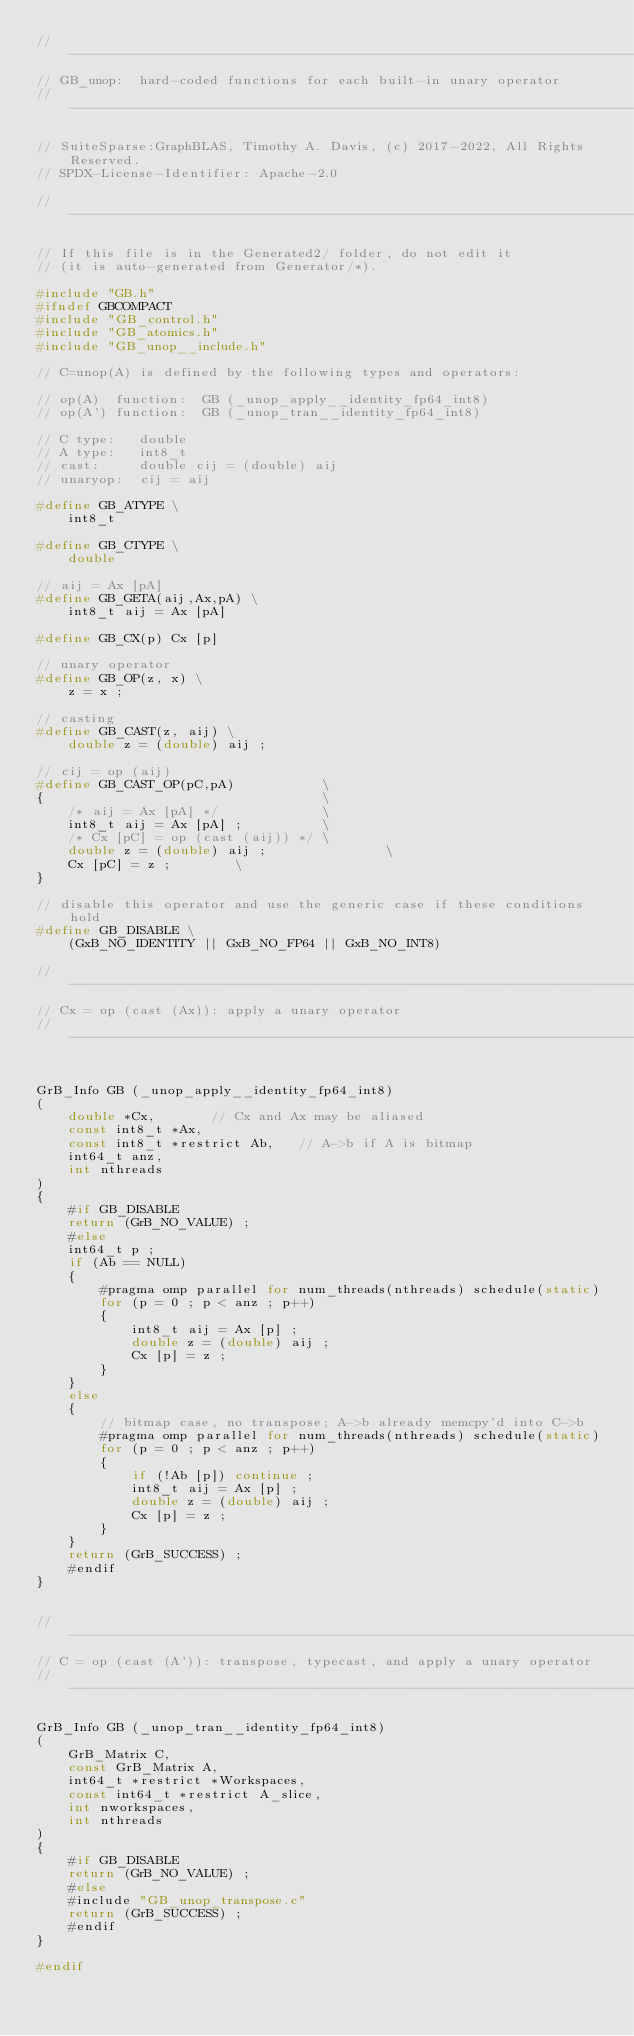Convert code to text. <code><loc_0><loc_0><loc_500><loc_500><_C_>//------------------------------------------------------------------------------
// GB_unop:  hard-coded functions for each built-in unary operator
//------------------------------------------------------------------------------

// SuiteSparse:GraphBLAS, Timothy A. Davis, (c) 2017-2022, All Rights Reserved.
// SPDX-License-Identifier: Apache-2.0

//------------------------------------------------------------------------------

// If this file is in the Generated2/ folder, do not edit it
// (it is auto-generated from Generator/*).

#include "GB.h"
#ifndef GBCOMPACT
#include "GB_control.h"
#include "GB_atomics.h"
#include "GB_unop__include.h"

// C=unop(A) is defined by the following types and operators:

// op(A)  function:  GB (_unop_apply__identity_fp64_int8)
// op(A') function:  GB (_unop_tran__identity_fp64_int8)

// C type:   double
// A type:   int8_t
// cast:     double cij = (double) aij
// unaryop:  cij = aij

#define GB_ATYPE \
    int8_t

#define GB_CTYPE \
    double

// aij = Ax [pA]
#define GB_GETA(aij,Ax,pA) \
    int8_t aij = Ax [pA]

#define GB_CX(p) Cx [p]

// unary operator
#define GB_OP(z, x) \
    z = x ;

// casting
#define GB_CAST(z, aij) \
    double z = (double) aij ;

// cij = op (aij)
#define GB_CAST_OP(pC,pA)           \
{                                   \
    /* aij = Ax [pA] */             \
    int8_t aij = Ax [pA] ;          \
    /* Cx [pC] = op (cast (aij)) */ \
    double z = (double) aij ;               \
    Cx [pC] = z ;        \
}

// disable this operator and use the generic case if these conditions hold
#define GB_DISABLE \
    (GxB_NO_IDENTITY || GxB_NO_FP64 || GxB_NO_INT8)

//------------------------------------------------------------------------------
// Cx = op (cast (Ax)): apply a unary operator
//------------------------------------------------------------------------------


GrB_Info GB (_unop_apply__identity_fp64_int8)
(
    double *Cx,       // Cx and Ax may be aliased
    const int8_t *Ax,
    const int8_t *restrict Ab,   // A->b if A is bitmap
    int64_t anz,
    int nthreads
)
{
    #if GB_DISABLE
    return (GrB_NO_VALUE) ;
    #else
    int64_t p ;
    if (Ab == NULL)
    { 
        #pragma omp parallel for num_threads(nthreads) schedule(static)
        for (p = 0 ; p < anz ; p++)
        {
            int8_t aij = Ax [p] ;
            double z = (double) aij ;
            Cx [p] = z ;
        }
    }
    else
    { 
        // bitmap case, no transpose; A->b already memcpy'd into C->b
        #pragma omp parallel for num_threads(nthreads) schedule(static)
        for (p = 0 ; p < anz ; p++)
        {
            if (!Ab [p]) continue ;
            int8_t aij = Ax [p] ;
            double z = (double) aij ;
            Cx [p] = z ;
        }
    }
    return (GrB_SUCCESS) ;
    #endif
}


//------------------------------------------------------------------------------
// C = op (cast (A')): transpose, typecast, and apply a unary operator
//------------------------------------------------------------------------------

GrB_Info GB (_unop_tran__identity_fp64_int8)
(
    GrB_Matrix C,
    const GrB_Matrix A,
    int64_t *restrict *Workspaces,
    const int64_t *restrict A_slice,
    int nworkspaces,
    int nthreads
)
{ 
    #if GB_DISABLE
    return (GrB_NO_VALUE) ;
    #else
    #include "GB_unop_transpose.c"
    return (GrB_SUCCESS) ;
    #endif
}

#endif

</code> 